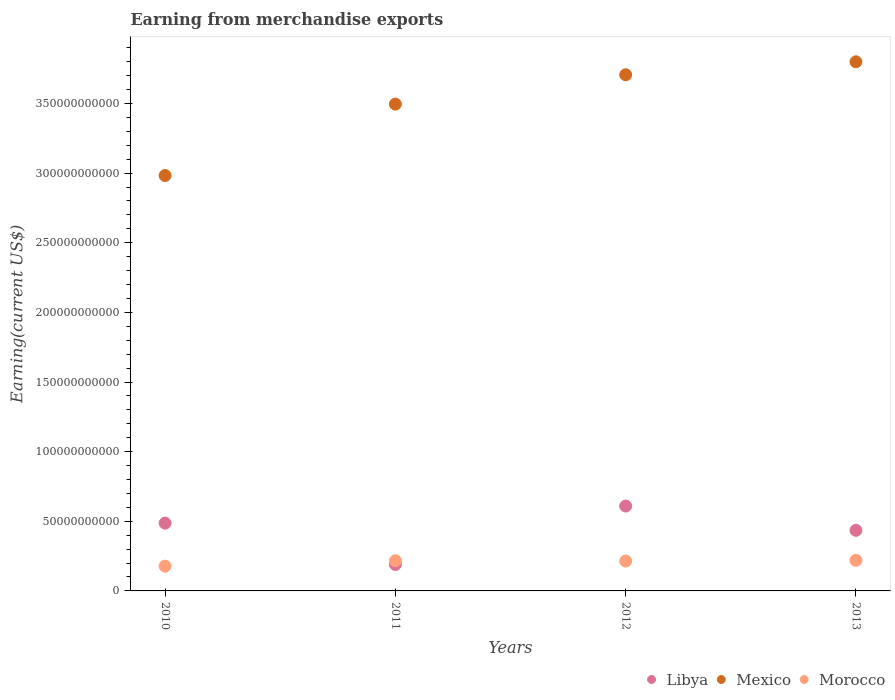How many different coloured dotlines are there?
Provide a succinct answer. 3. Is the number of dotlines equal to the number of legend labels?
Your answer should be very brief. Yes. What is the amount earned from merchandise exports in Mexico in 2010?
Your answer should be compact. 2.98e+11. Across all years, what is the maximum amount earned from merchandise exports in Mexico?
Provide a short and direct response. 3.80e+11. Across all years, what is the minimum amount earned from merchandise exports in Morocco?
Ensure brevity in your answer.  1.78e+1. What is the total amount earned from merchandise exports in Mexico in the graph?
Your response must be concise. 1.40e+12. What is the difference between the amount earned from merchandise exports in Libya in 2010 and that in 2013?
Give a very brief answer. 5.17e+09. What is the difference between the amount earned from merchandise exports in Libya in 2013 and the amount earned from merchandise exports in Morocco in 2012?
Your answer should be compact. 2.21e+1. What is the average amount earned from merchandise exports in Mexico per year?
Your response must be concise. 3.50e+11. In the year 2012, what is the difference between the amount earned from merchandise exports in Mexico and amount earned from merchandise exports in Morocco?
Provide a short and direct response. 3.49e+11. What is the ratio of the amount earned from merchandise exports in Libya in 2010 to that in 2013?
Provide a succinct answer. 1.12. Is the amount earned from merchandise exports in Mexico in 2011 less than that in 2012?
Your answer should be compact. Yes. Is the difference between the amount earned from merchandise exports in Mexico in 2011 and 2012 greater than the difference between the amount earned from merchandise exports in Morocco in 2011 and 2012?
Offer a terse response. No. What is the difference between the highest and the second highest amount earned from merchandise exports in Morocco?
Offer a very short reply. 3.18e+08. What is the difference between the highest and the lowest amount earned from merchandise exports in Libya?
Offer a terse response. 4.19e+1. In how many years, is the amount earned from merchandise exports in Libya greater than the average amount earned from merchandise exports in Libya taken over all years?
Your answer should be compact. 3. Is the amount earned from merchandise exports in Libya strictly less than the amount earned from merchandise exports in Morocco over the years?
Offer a very short reply. No. How many dotlines are there?
Offer a very short reply. 3. Are the values on the major ticks of Y-axis written in scientific E-notation?
Your answer should be compact. No. Does the graph contain any zero values?
Your answer should be compact. No. Does the graph contain grids?
Provide a short and direct response. No. How many legend labels are there?
Your response must be concise. 3. How are the legend labels stacked?
Provide a succinct answer. Horizontal. What is the title of the graph?
Give a very brief answer. Earning from merchandise exports. Does "Chile" appear as one of the legend labels in the graph?
Offer a terse response. No. What is the label or title of the Y-axis?
Offer a very short reply. Earning(current US$). What is the Earning(current US$) in Libya in 2010?
Provide a short and direct response. 4.87e+1. What is the Earning(current US$) in Mexico in 2010?
Provide a short and direct response. 2.98e+11. What is the Earning(current US$) of Morocco in 2010?
Provide a short and direct response. 1.78e+1. What is the Earning(current US$) of Libya in 2011?
Your answer should be very brief. 1.90e+1. What is the Earning(current US$) in Mexico in 2011?
Provide a short and direct response. 3.50e+11. What is the Earning(current US$) of Morocco in 2011?
Your answer should be very brief. 2.17e+1. What is the Earning(current US$) of Libya in 2012?
Provide a succinct answer. 6.09e+1. What is the Earning(current US$) of Mexico in 2012?
Your response must be concise. 3.71e+11. What is the Earning(current US$) in Morocco in 2012?
Give a very brief answer. 2.14e+1. What is the Earning(current US$) in Libya in 2013?
Offer a terse response. 4.35e+1. What is the Earning(current US$) in Mexico in 2013?
Provide a succinct answer. 3.80e+11. What is the Earning(current US$) of Morocco in 2013?
Make the answer very short. 2.20e+1. Across all years, what is the maximum Earning(current US$) in Libya?
Provide a short and direct response. 6.09e+1. Across all years, what is the maximum Earning(current US$) in Mexico?
Provide a short and direct response. 3.80e+11. Across all years, what is the maximum Earning(current US$) of Morocco?
Offer a very short reply. 2.20e+1. Across all years, what is the minimum Earning(current US$) of Libya?
Ensure brevity in your answer.  1.90e+1. Across all years, what is the minimum Earning(current US$) of Mexico?
Offer a terse response. 2.98e+11. Across all years, what is the minimum Earning(current US$) of Morocco?
Ensure brevity in your answer.  1.78e+1. What is the total Earning(current US$) in Libya in the graph?
Make the answer very short. 1.72e+11. What is the total Earning(current US$) in Mexico in the graph?
Your answer should be compact. 1.40e+12. What is the total Earning(current US$) of Morocco in the graph?
Ensure brevity in your answer.  8.28e+1. What is the difference between the Earning(current US$) in Libya in 2010 and that in 2011?
Offer a terse response. 2.97e+1. What is the difference between the Earning(current US$) of Mexico in 2010 and that in 2011?
Make the answer very short. -5.13e+1. What is the difference between the Earning(current US$) of Morocco in 2010 and that in 2011?
Provide a succinct answer. -3.88e+09. What is the difference between the Earning(current US$) in Libya in 2010 and that in 2012?
Make the answer very short. -1.23e+1. What is the difference between the Earning(current US$) of Mexico in 2010 and that in 2012?
Keep it short and to the point. -7.23e+1. What is the difference between the Earning(current US$) of Morocco in 2010 and that in 2012?
Provide a succinct answer. -3.68e+09. What is the difference between the Earning(current US$) in Libya in 2010 and that in 2013?
Your answer should be very brief. 5.17e+09. What is the difference between the Earning(current US$) in Mexico in 2010 and that in 2013?
Your answer should be compact. -8.17e+1. What is the difference between the Earning(current US$) of Morocco in 2010 and that in 2013?
Your answer should be compact. -4.20e+09. What is the difference between the Earning(current US$) of Libya in 2011 and that in 2012?
Keep it short and to the point. -4.19e+1. What is the difference between the Earning(current US$) of Mexico in 2011 and that in 2012?
Keep it short and to the point. -2.11e+1. What is the difference between the Earning(current US$) of Morocco in 2011 and that in 2012?
Your answer should be very brief. 2.08e+08. What is the difference between the Earning(current US$) in Libya in 2011 and that in 2013?
Your answer should be very brief. -2.45e+1. What is the difference between the Earning(current US$) in Mexico in 2011 and that in 2013?
Ensure brevity in your answer.  -3.04e+1. What is the difference between the Earning(current US$) of Morocco in 2011 and that in 2013?
Your answer should be compact. -3.18e+08. What is the difference between the Earning(current US$) of Libya in 2012 and that in 2013?
Your response must be concise. 1.74e+1. What is the difference between the Earning(current US$) in Mexico in 2012 and that in 2013?
Ensure brevity in your answer.  -9.32e+09. What is the difference between the Earning(current US$) of Morocco in 2012 and that in 2013?
Make the answer very short. -5.26e+08. What is the difference between the Earning(current US$) of Libya in 2010 and the Earning(current US$) of Mexico in 2011?
Ensure brevity in your answer.  -3.01e+11. What is the difference between the Earning(current US$) in Libya in 2010 and the Earning(current US$) in Morocco in 2011?
Ensure brevity in your answer.  2.70e+1. What is the difference between the Earning(current US$) in Mexico in 2010 and the Earning(current US$) in Morocco in 2011?
Provide a succinct answer. 2.77e+11. What is the difference between the Earning(current US$) in Libya in 2010 and the Earning(current US$) in Mexico in 2012?
Your answer should be compact. -3.22e+11. What is the difference between the Earning(current US$) of Libya in 2010 and the Earning(current US$) of Morocco in 2012?
Give a very brief answer. 2.72e+1. What is the difference between the Earning(current US$) of Mexico in 2010 and the Earning(current US$) of Morocco in 2012?
Provide a succinct answer. 2.77e+11. What is the difference between the Earning(current US$) in Libya in 2010 and the Earning(current US$) in Mexico in 2013?
Give a very brief answer. -3.31e+11. What is the difference between the Earning(current US$) in Libya in 2010 and the Earning(current US$) in Morocco in 2013?
Provide a succinct answer. 2.67e+1. What is the difference between the Earning(current US$) in Mexico in 2010 and the Earning(current US$) in Morocco in 2013?
Make the answer very short. 2.76e+11. What is the difference between the Earning(current US$) in Libya in 2011 and the Earning(current US$) in Mexico in 2012?
Your answer should be very brief. -3.52e+11. What is the difference between the Earning(current US$) in Libya in 2011 and the Earning(current US$) in Morocco in 2012?
Offer a very short reply. -2.45e+09. What is the difference between the Earning(current US$) in Mexico in 2011 and the Earning(current US$) in Morocco in 2012?
Provide a short and direct response. 3.28e+11. What is the difference between the Earning(current US$) in Libya in 2011 and the Earning(current US$) in Mexico in 2013?
Your answer should be very brief. -3.61e+11. What is the difference between the Earning(current US$) of Libya in 2011 and the Earning(current US$) of Morocco in 2013?
Offer a terse response. -2.98e+09. What is the difference between the Earning(current US$) of Mexico in 2011 and the Earning(current US$) of Morocco in 2013?
Your answer should be very brief. 3.28e+11. What is the difference between the Earning(current US$) of Libya in 2012 and the Earning(current US$) of Mexico in 2013?
Your response must be concise. -3.19e+11. What is the difference between the Earning(current US$) in Libya in 2012 and the Earning(current US$) in Morocco in 2013?
Your response must be concise. 3.90e+1. What is the difference between the Earning(current US$) in Mexico in 2012 and the Earning(current US$) in Morocco in 2013?
Keep it short and to the point. 3.49e+11. What is the average Earning(current US$) of Libya per year?
Your answer should be very brief. 4.30e+1. What is the average Earning(current US$) of Mexico per year?
Make the answer very short. 3.50e+11. What is the average Earning(current US$) of Morocco per year?
Your answer should be very brief. 2.07e+1. In the year 2010, what is the difference between the Earning(current US$) in Libya and Earning(current US$) in Mexico?
Offer a terse response. -2.50e+11. In the year 2010, what is the difference between the Earning(current US$) in Libya and Earning(current US$) in Morocco?
Your answer should be compact. 3.09e+1. In the year 2010, what is the difference between the Earning(current US$) of Mexico and Earning(current US$) of Morocco?
Provide a succinct answer. 2.81e+11. In the year 2011, what is the difference between the Earning(current US$) of Libya and Earning(current US$) of Mexico?
Your response must be concise. -3.31e+11. In the year 2011, what is the difference between the Earning(current US$) in Libya and Earning(current US$) in Morocco?
Offer a terse response. -2.66e+09. In the year 2011, what is the difference between the Earning(current US$) of Mexico and Earning(current US$) of Morocco?
Give a very brief answer. 3.28e+11. In the year 2012, what is the difference between the Earning(current US$) in Libya and Earning(current US$) in Mexico?
Keep it short and to the point. -3.10e+11. In the year 2012, what is the difference between the Earning(current US$) in Libya and Earning(current US$) in Morocco?
Your response must be concise. 3.95e+1. In the year 2012, what is the difference between the Earning(current US$) in Mexico and Earning(current US$) in Morocco?
Your answer should be compact. 3.49e+11. In the year 2013, what is the difference between the Earning(current US$) in Libya and Earning(current US$) in Mexico?
Your response must be concise. -3.36e+11. In the year 2013, what is the difference between the Earning(current US$) in Libya and Earning(current US$) in Morocco?
Provide a short and direct response. 2.15e+1. In the year 2013, what is the difference between the Earning(current US$) in Mexico and Earning(current US$) in Morocco?
Your response must be concise. 3.58e+11. What is the ratio of the Earning(current US$) in Libya in 2010 to that in 2011?
Keep it short and to the point. 2.56. What is the ratio of the Earning(current US$) of Mexico in 2010 to that in 2011?
Make the answer very short. 0.85. What is the ratio of the Earning(current US$) in Morocco in 2010 to that in 2011?
Offer a terse response. 0.82. What is the ratio of the Earning(current US$) of Libya in 2010 to that in 2012?
Provide a succinct answer. 0.8. What is the ratio of the Earning(current US$) in Mexico in 2010 to that in 2012?
Provide a short and direct response. 0.8. What is the ratio of the Earning(current US$) of Morocco in 2010 to that in 2012?
Offer a terse response. 0.83. What is the ratio of the Earning(current US$) in Libya in 2010 to that in 2013?
Your answer should be compact. 1.12. What is the ratio of the Earning(current US$) of Mexico in 2010 to that in 2013?
Provide a succinct answer. 0.79. What is the ratio of the Earning(current US$) in Morocco in 2010 to that in 2013?
Give a very brief answer. 0.81. What is the ratio of the Earning(current US$) in Libya in 2011 to that in 2012?
Provide a short and direct response. 0.31. What is the ratio of the Earning(current US$) of Mexico in 2011 to that in 2012?
Provide a succinct answer. 0.94. What is the ratio of the Earning(current US$) of Morocco in 2011 to that in 2012?
Your answer should be compact. 1.01. What is the ratio of the Earning(current US$) in Libya in 2011 to that in 2013?
Your answer should be compact. 0.44. What is the ratio of the Earning(current US$) in Morocco in 2011 to that in 2013?
Your response must be concise. 0.99. What is the ratio of the Earning(current US$) in Libya in 2012 to that in 2013?
Offer a very short reply. 1.4. What is the ratio of the Earning(current US$) of Mexico in 2012 to that in 2013?
Your response must be concise. 0.98. What is the ratio of the Earning(current US$) in Morocco in 2012 to that in 2013?
Offer a very short reply. 0.98. What is the difference between the highest and the second highest Earning(current US$) of Libya?
Make the answer very short. 1.23e+1. What is the difference between the highest and the second highest Earning(current US$) in Mexico?
Offer a terse response. 9.32e+09. What is the difference between the highest and the second highest Earning(current US$) of Morocco?
Provide a succinct answer. 3.18e+08. What is the difference between the highest and the lowest Earning(current US$) of Libya?
Your answer should be very brief. 4.19e+1. What is the difference between the highest and the lowest Earning(current US$) of Mexico?
Provide a succinct answer. 8.17e+1. What is the difference between the highest and the lowest Earning(current US$) of Morocco?
Ensure brevity in your answer.  4.20e+09. 